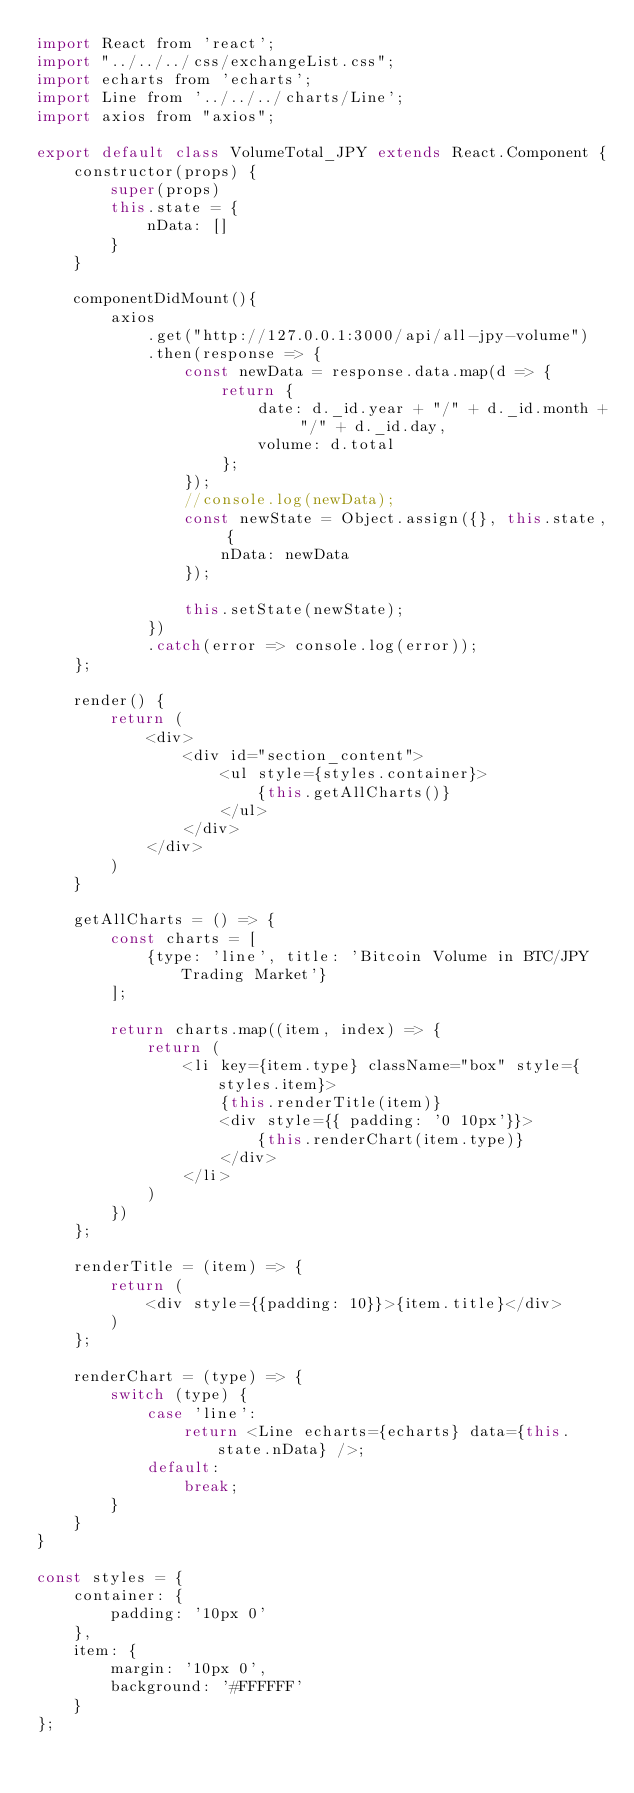Convert code to text. <code><loc_0><loc_0><loc_500><loc_500><_JavaScript_>import React from 'react';
import "../../../css/exchangeList.css";
import echarts from 'echarts';
import Line from '../../../charts/Line';
import axios from "axios";

export default class VolumeTotal_JPY extends React.Component {
    constructor(props) {
        super(props)
        this.state = {
            nData: []
        }
    }

    componentDidMount(){
        axios
            .get("http://127.0.0.1:3000/api/all-jpy-volume")
            .then(response => {
                const newData = response.data.map(d => {
                    return {
                        date: d._id.year + "/" + d._id.month + "/" + d._id.day,
                        volume: d.total
                    };
                });
                //console.log(newData);
                const newState = Object.assign({}, this.state, {
                    nData: newData
                });

                this.setState(newState);
            })
            .catch(error => console.log(error));
    };

    render() {
        return (
            <div>
                <div id="section_content">
                    <ul style={styles.container}>
                        {this.getAllCharts()}
                    </ul>
                </div>
            </div>
        )
    }

    getAllCharts = () => {
        const charts = [
            {type: 'line', title: 'Bitcoin Volume in BTC/JPY Trading Market'}
        ];

        return charts.map((item, index) => {
            return (
                <li key={item.type} className="box" style={styles.item}>
                    {this.renderTitle(item)}
                    <div style={{ padding: '0 10px'}}>
                        {this.renderChart(item.type)}
                    </div>
                </li>
            )
        })
    };

    renderTitle = (item) => {
        return (
            <div style={{padding: 10}}>{item.title}</div>
        )
    };

    renderChart = (type) => {
        switch (type) {
            case 'line':
                return <Line echarts={echarts} data={this.state.nData} />;
            default:
                break;
        }
    }
}

const styles = {
    container: {
        padding: '10px 0'
    },
    item: {
        margin: '10px 0',
        background: '#FFFFFF'
    }
};</code> 